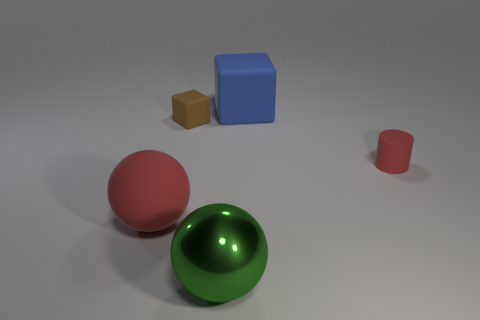There is a big matte thing in front of the tiny red matte cylinder that is on the right side of the metallic sphere; how many rubber things are behind it? Behind the large blue cube, which is situated in front of the small red cylinder on the right side of the shiny, metallic sphere, there appear to be no rubber objects. The scene consists only of solid items, some with matte textures and one metallic, without any visible rubber materials. 